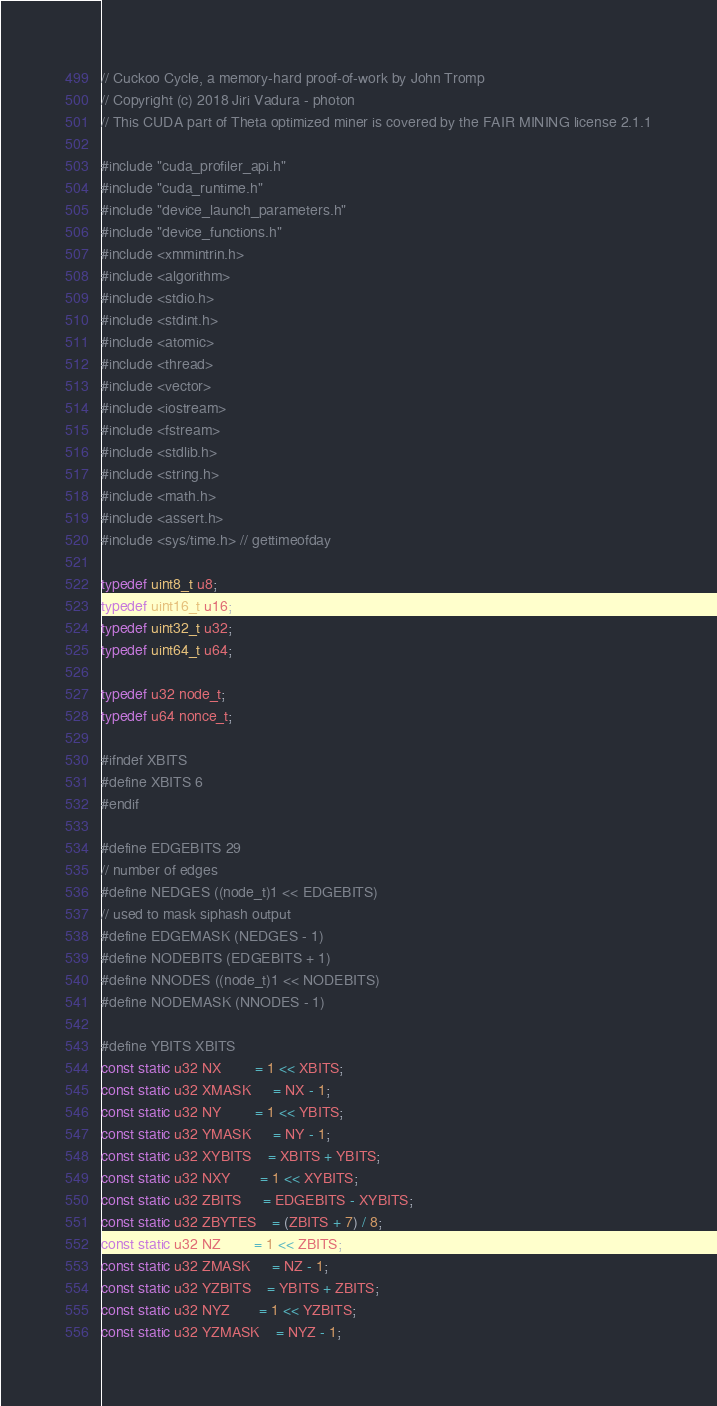Convert code to text. <code><loc_0><loc_0><loc_500><loc_500><_Cuda_>// Cuckoo Cycle, a memory-hard proof-of-work by John Tromp
// Copyright (c) 2018 Jiri Vadura - photon
// This CUDA part of Theta optimized miner is covered by the FAIR MINING license 2.1.1

#include "cuda_profiler_api.h"
#include "cuda_runtime.h"
#include "device_launch_parameters.h"
#include "device_functions.h"
#include <xmmintrin.h>
#include <algorithm>
#include <stdio.h>
#include <stdint.h>
#include <atomic>
#include <thread>
#include <vector>
#include <iostream>
#include <fstream>
#include <stdlib.h>
#include <string.h>
#include <math.h>
#include <assert.h>
#include <sys/time.h> // gettimeofday

typedef uint8_t u8;
typedef uint16_t u16;
typedef uint32_t u32;
typedef uint64_t u64;

typedef u32 node_t;
typedef u64 nonce_t;

#ifndef XBITS
#define XBITS 6
#endif

#define EDGEBITS 29
// number of edges
#define NEDGES ((node_t)1 << EDGEBITS)
// used to mask siphash output
#define EDGEMASK (NEDGES - 1)
#define NODEBITS (EDGEBITS + 1)
#define NNODES ((node_t)1 << NODEBITS)
#define NODEMASK (NNODES - 1)

#define YBITS XBITS
const static u32 NX        = 1 << XBITS;
const static u32 XMASK     = NX - 1;
const static u32 NY        = 1 << YBITS;
const static u32 YMASK     = NY - 1;
const static u32 XYBITS    = XBITS + YBITS;
const static u32 NXY       = 1 << XYBITS;
const static u32 ZBITS     = EDGEBITS - XYBITS;
const static u32 ZBYTES    = (ZBITS + 7) / 8;
const static u32 NZ        = 1 << ZBITS;
const static u32 ZMASK     = NZ - 1;
const static u32 YZBITS    = YBITS + ZBITS;
const static u32 NYZ       = 1 << YZBITS;
const static u32 YZMASK    = NYZ - 1;
</code> 